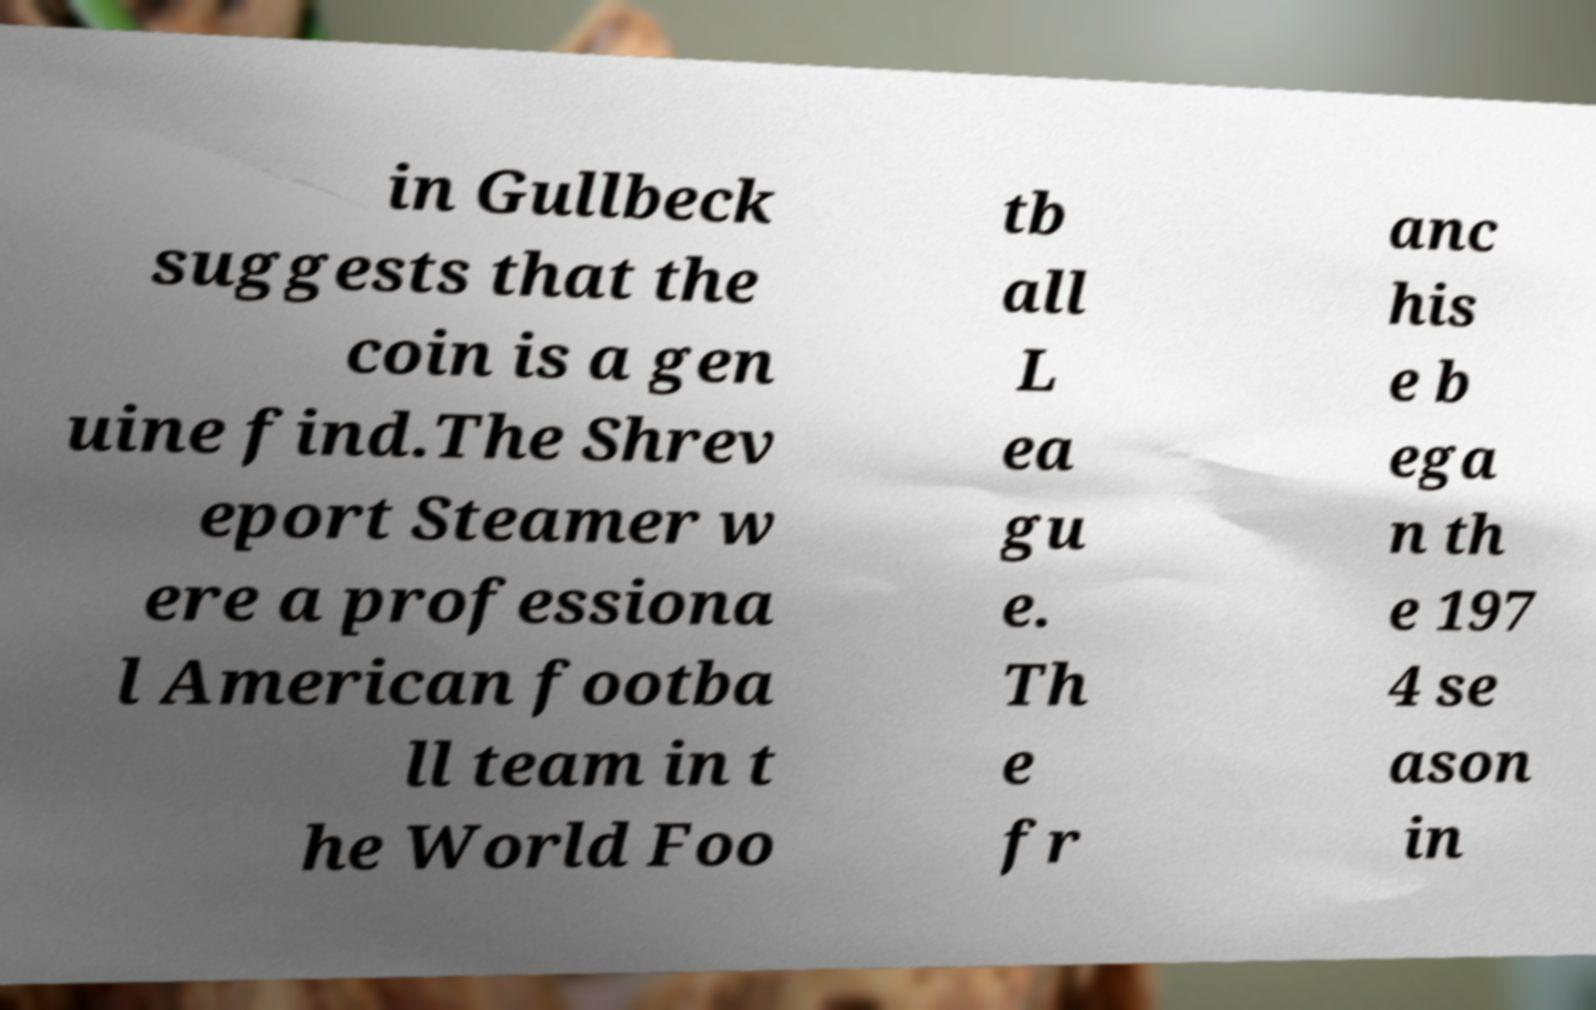For documentation purposes, I need the text within this image transcribed. Could you provide that? in Gullbeck suggests that the coin is a gen uine find.The Shrev eport Steamer w ere a professiona l American footba ll team in t he World Foo tb all L ea gu e. Th e fr anc his e b ega n th e 197 4 se ason in 